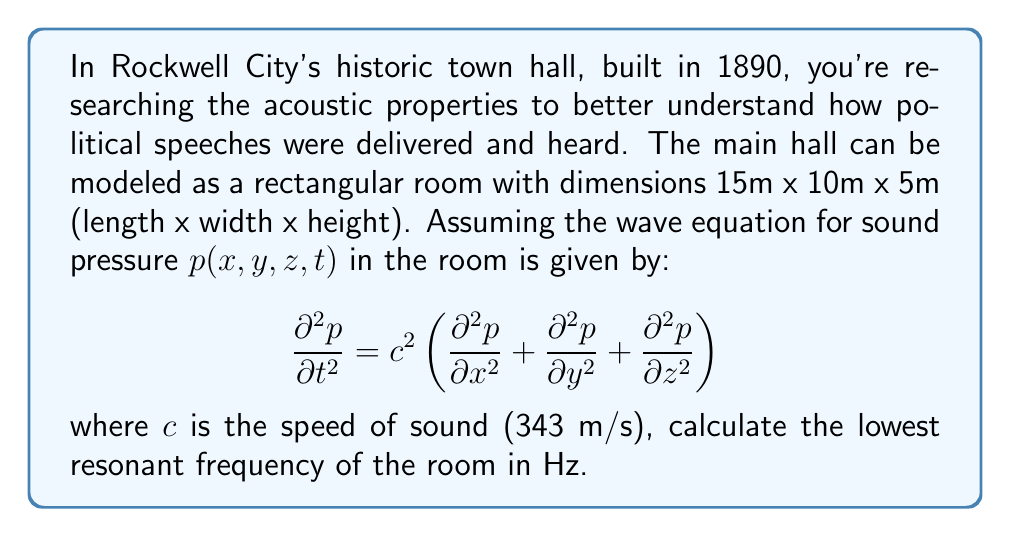Give your solution to this math problem. To find the lowest resonant frequency, we need to solve the wave equation with appropriate boundary conditions. For a rectangular room, the solution takes the form:

$$p(x,y,z,t) = \cos(\omega t) \cos(k_x x) \cos(k_y y) \cos(k_z z)$$

where $\omega$ is the angular frequency, and $k_x$, $k_y$, and $k_z$ are wavenumbers in the x, y, and z directions respectively.

The boundary conditions for a rigid-walled room require that the normal component of particle velocity is zero at the walls. This leads to:

$$k_x = \frac{n_x \pi}{L_x}, k_y = \frac{n_y \pi}{L_y}, k_z = \frac{n_z \pi}{L_z}$$

where $n_x$, $n_y$, and $n_z$ are non-negative integers, and $L_x$, $L_y$, and $L_z$ are the room dimensions.

The dispersion relation connects $\omega$ to the wavenumbers:

$$\omega^2 = c^2(k_x^2 + k_y^2 + k_z^2)$$

Substituting the expressions for $k_x$, $k_y$, and $k_z$:

$$\omega^2 = c^2 \pi^2 \left(\frac{n_x^2}{L_x^2} + \frac{n_y^2}{L_y^2} + \frac{n_z^2}{L_z^2}\right)$$

The lowest resonant frequency occurs when $n_x = 1$, $n_y = 0$, and $n_z = 0$. Therefore:

$$\omega^2 = c^2 \pi^2 \left(\frac{1^2}{L_x^2} + \frac{0^2}{L_y^2} + \frac{0^2}{L_z^2}\right) = \frac{c^2 \pi^2}{L_x^2}$$

$$\omega = \frac{c \pi}{L_x}$$

The frequency $f$ is related to $\omega$ by $f = \frac{\omega}{2\pi}$, so:

$$f = \frac{c}{2L_x} = \frac{343 \text{ m/s}}{2 \cdot 15 \text{ m}} = 11.43 \text{ Hz}$$
Answer: 11.43 Hz 